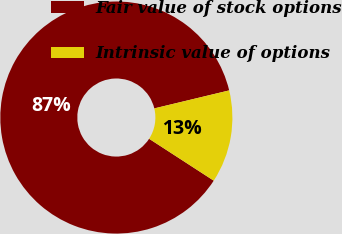Convert chart. <chart><loc_0><loc_0><loc_500><loc_500><pie_chart><fcel>Fair value of stock options<fcel>Intrinsic value of options<nl><fcel>87.09%<fcel>12.91%<nl></chart> 